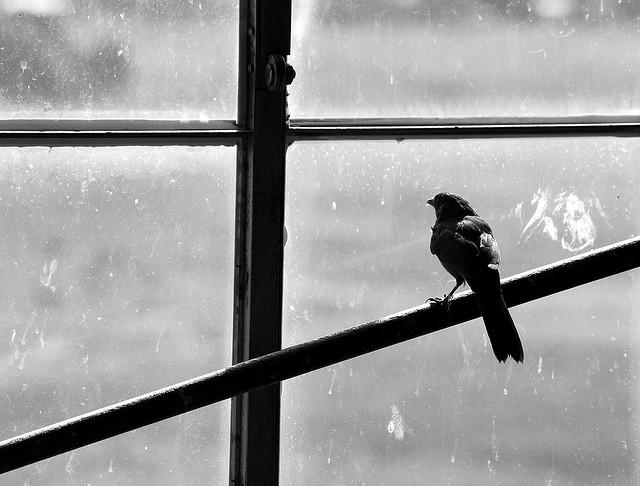What animal is in the picture?
Write a very short answer. Bird. What color is this picture?
Answer briefly. Black and white. Can this animal fly?
Give a very brief answer. Yes. 